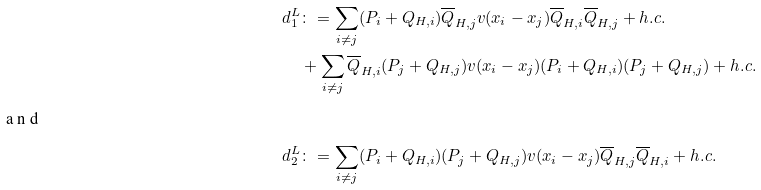Convert formula to latex. <formula><loc_0><loc_0><loc_500><loc_500>d _ { 1 } ^ { L } & \colon = \sum _ { i \neq j } ( P _ { i } + Q _ { H , i } ) \overline { Q } _ { H , j } v ( x _ { i } - x _ { j } ) \overline { Q } _ { H , i } \overline { Q } _ { H , j } + h . c . \\ & + \sum _ { i \neq j } \overline { Q } _ { H , i } ( P _ { j } + Q _ { H , j } ) v ( x _ { i } - x _ { j } ) ( P _ { i } + Q _ { H , i } ) ( P _ { j } + Q _ { H , j } ) + h . c . \intertext { a n d } d _ { 2 } ^ { L } & \colon = \sum _ { i \neq j } ( P _ { i } + Q _ { H , i } ) ( P _ { j } + Q _ { H , j } ) v ( x _ { i } - x _ { j } ) \overline { Q } _ { H , j } \overline { Q } _ { H , i } + h . c .</formula> 